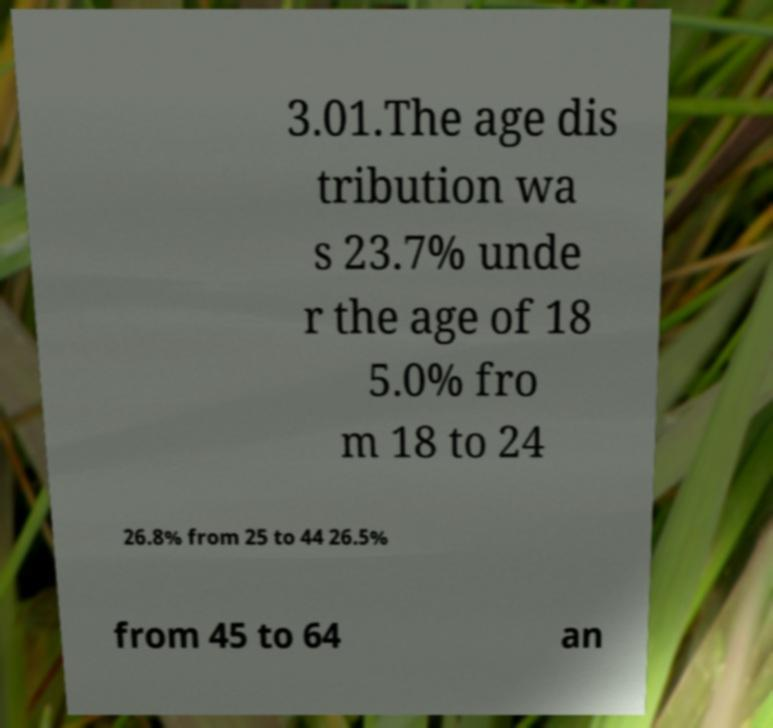Can you accurately transcribe the text from the provided image for me? 3.01.The age dis tribution wa s 23.7% unde r the age of 18 5.0% fro m 18 to 24 26.8% from 25 to 44 26.5% from 45 to 64 an 